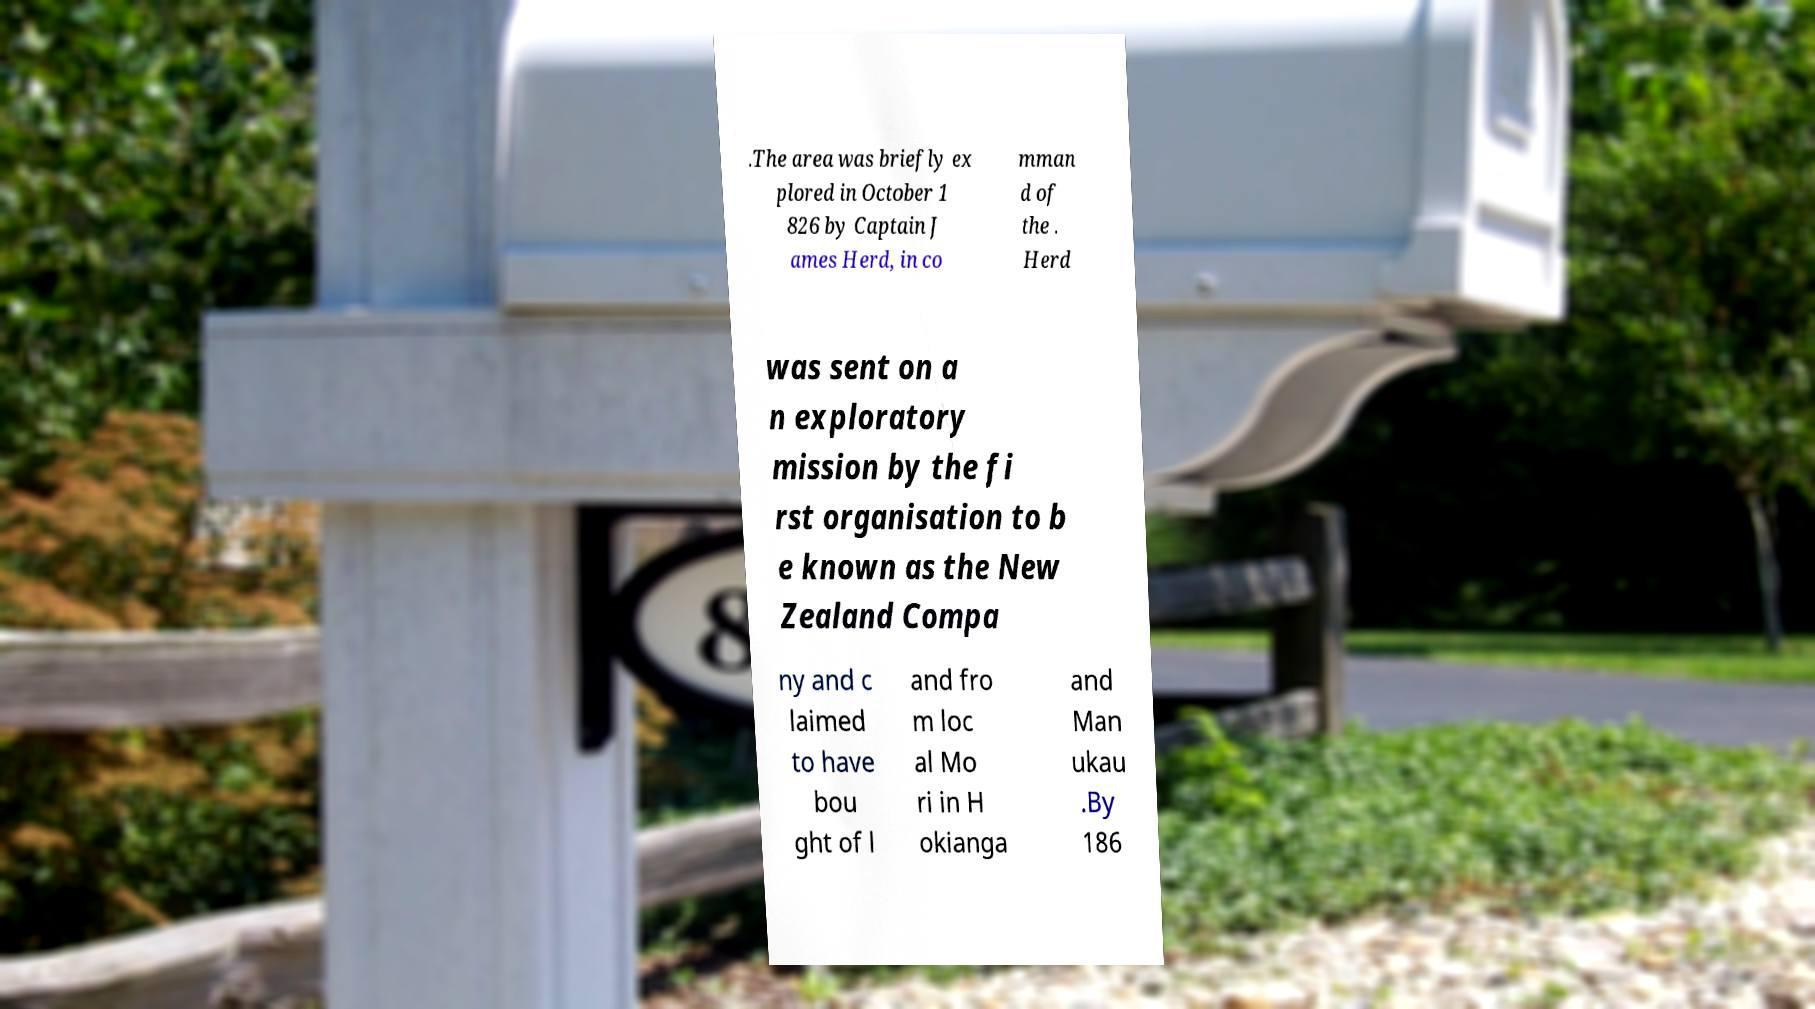I need the written content from this picture converted into text. Can you do that? .The area was briefly ex plored in October 1 826 by Captain J ames Herd, in co mman d of the . Herd was sent on a n exploratory mission by the fi rst organisation to b e known as the New Zealand Compa ny and c laimed to have bou ght of l and fro m loc al Mo ri in H okianga and Man ukau .By 186 